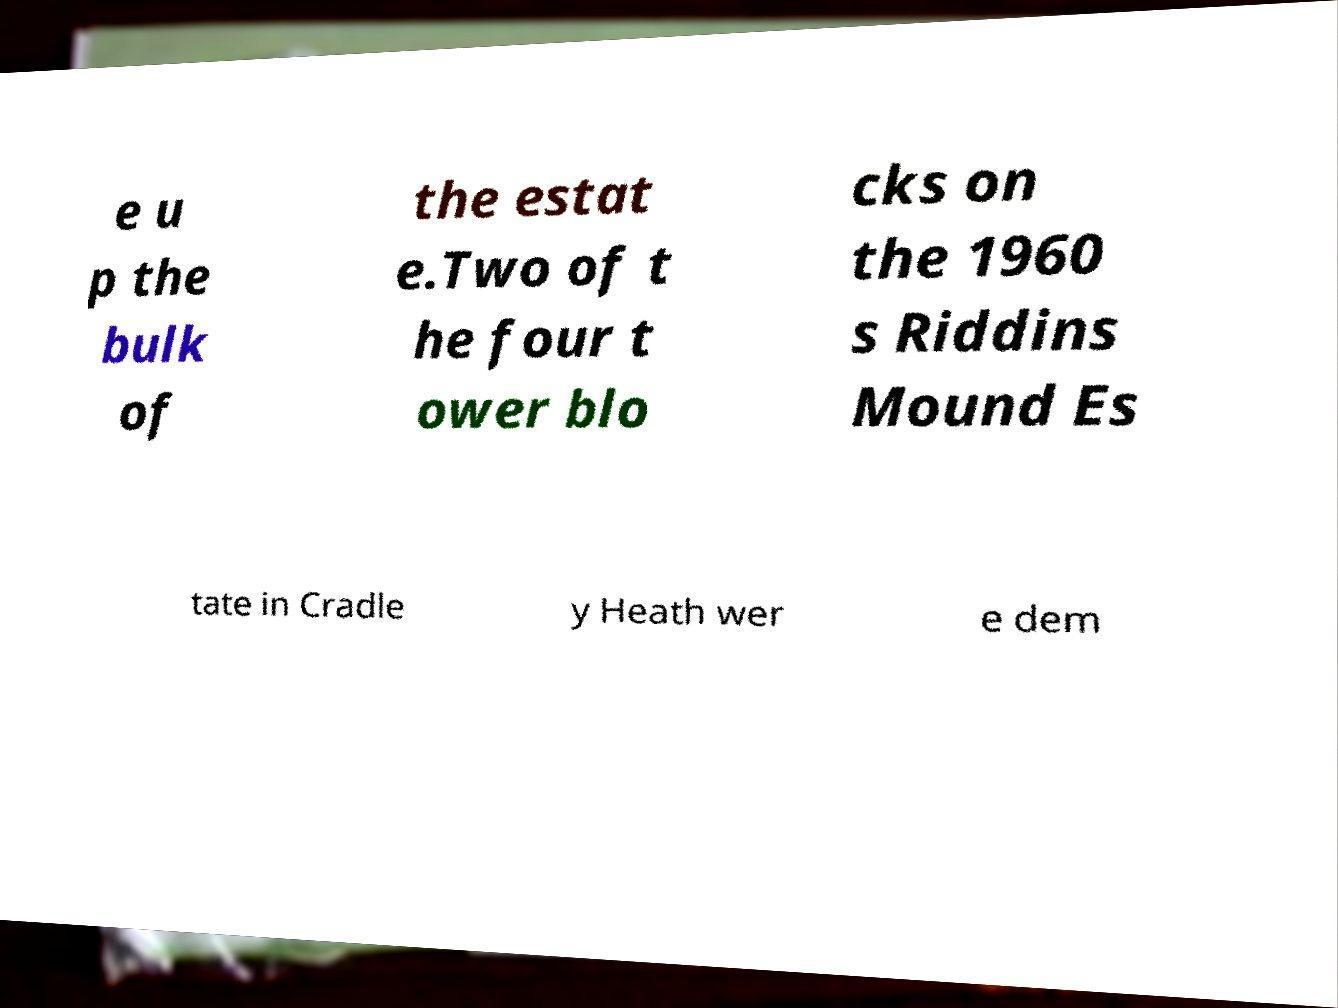Can you read and provide the text displayed in the image?This photo seems to have some interesting text. Can you extract and type it out for me? e u p the bulk of the estat e.Two of t he four t ower blo cks on the 1960 s Riddins Mound Es tate in Cradle y Heath wer e dem 